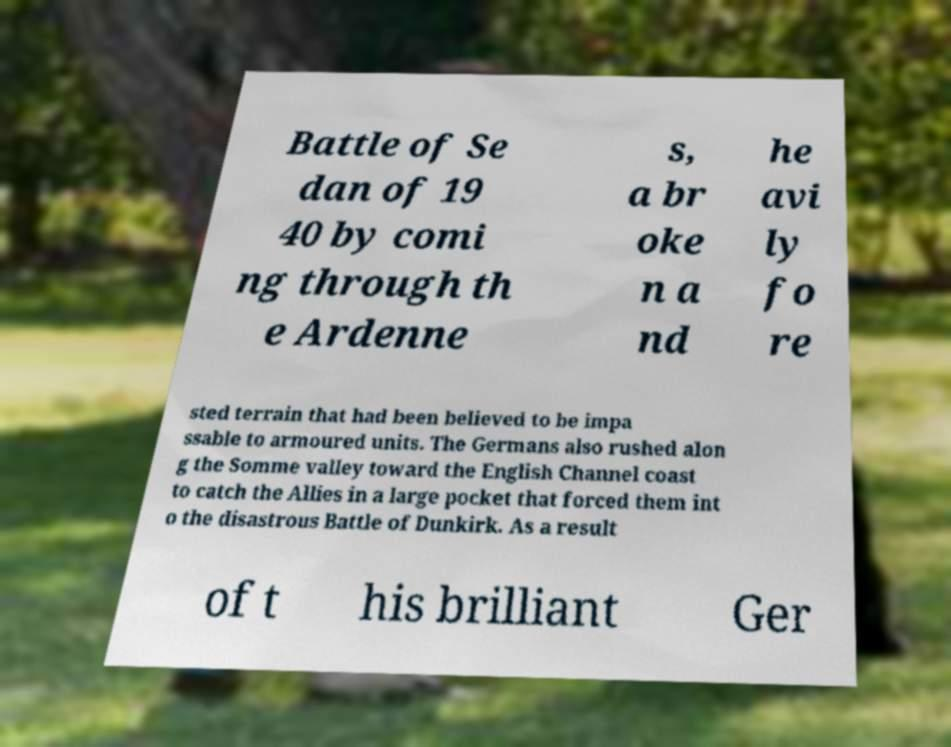Can you accurately transcribe the text from the provided image for me? Battle of Se dan of 19 40 by comi ng through th e Ardenne s, a br oke n a nd he avi ly fo re sted terrain that had been believed to be impa ssable to armoured units. The Germans also rushed alon g the Somme valley toward the English Channel coast to catch the Allies in a large pocket that forced them int o the disastrous Battle of Dunkirk. As a result of t his brilliant Ger 